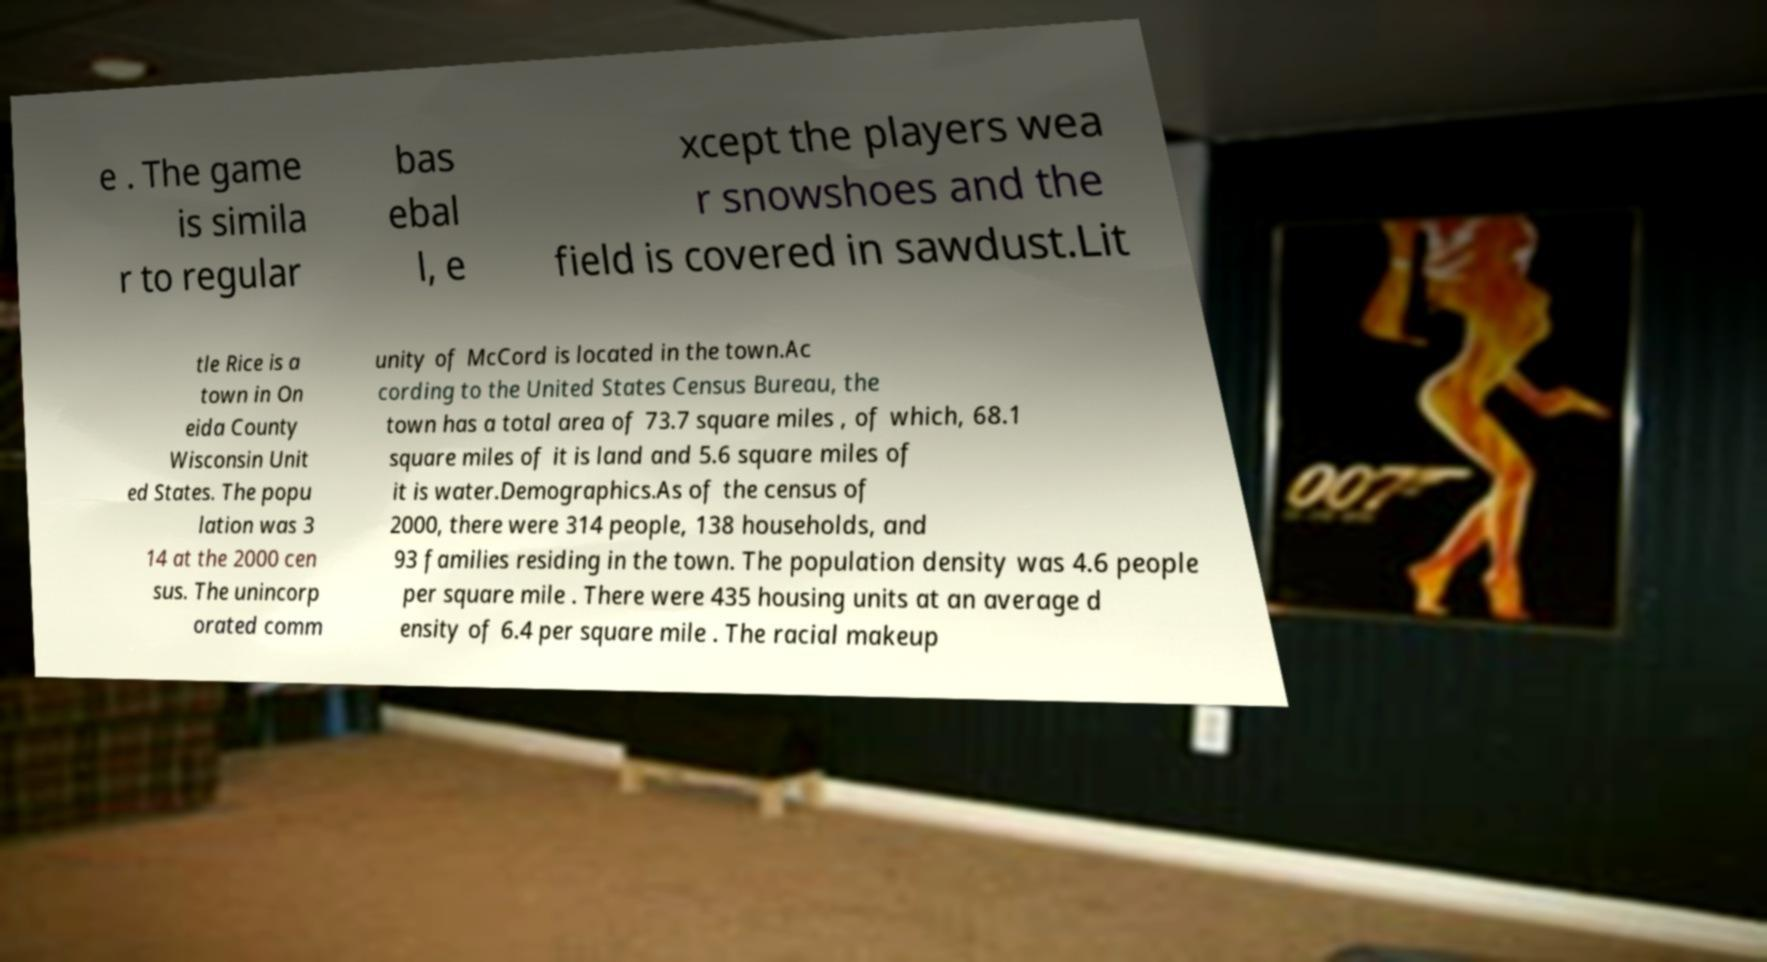Please read and relay the text visible in this image. What does it say? e . The game is simila r to regular bas ebal l, e xcept the players wea r snowshoes and the field is covered in sawdust.Lit tle Rice is a town in On eida County Wisconsin Unit ed States. The popu lation was 3 14 at the 2000 cen sus. The unincorp orated comm unity of McCord is located in the town.Ac cording to the United States Census Bureau, the town has a total area of 73.7 square miles , of which, 68.1 square miles of it is land and 5.6 square miles of it is water.Demographics.As of the census of 2000, there were 314 people, 138 households, and 93 families residing in the town. The population density was 4.6 people per square mile . There were 435 housing units at an average d ensity of 6.4 per square mile . The racial makeup 